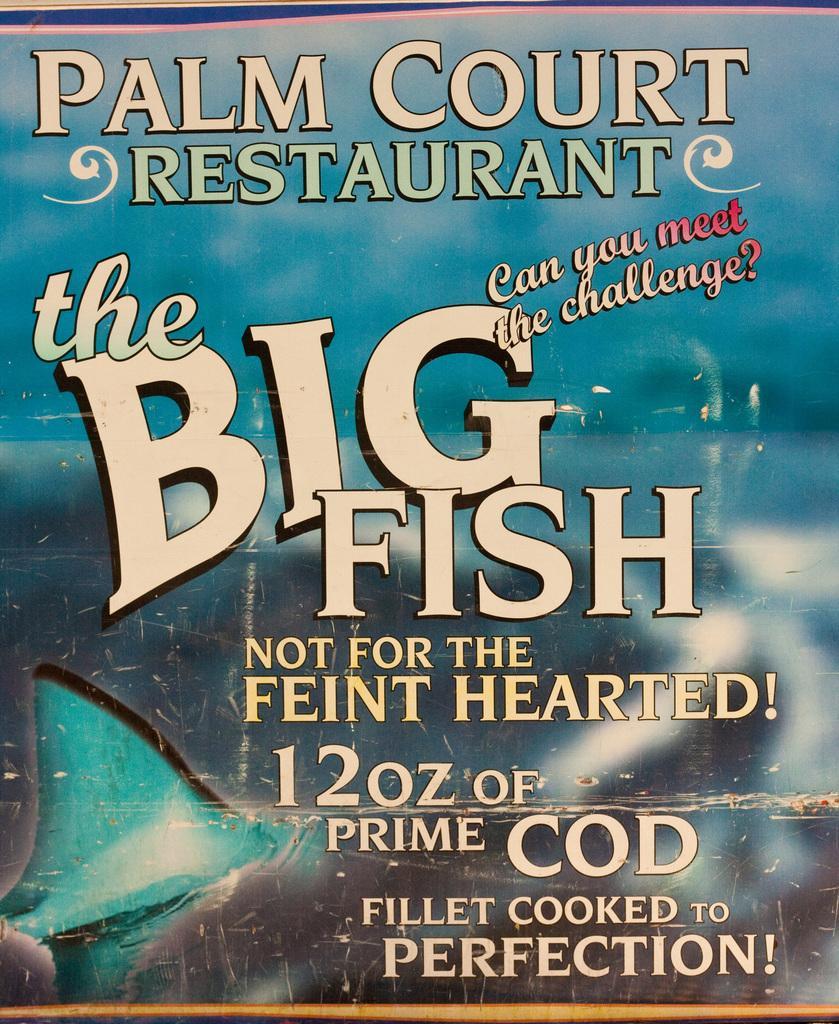Could you give a brief overview of what you see in this image? This is a poster having an animated image and texts. This animated image is blurred. 